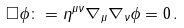<formula> <loc_0><loc_0><loc_500><loc_500>\square \phi \colon = \eta ^ { \mu \nu } \nabla _ { \mu } \nabla _ { \nu } \phi = 0 \, .</formula> 